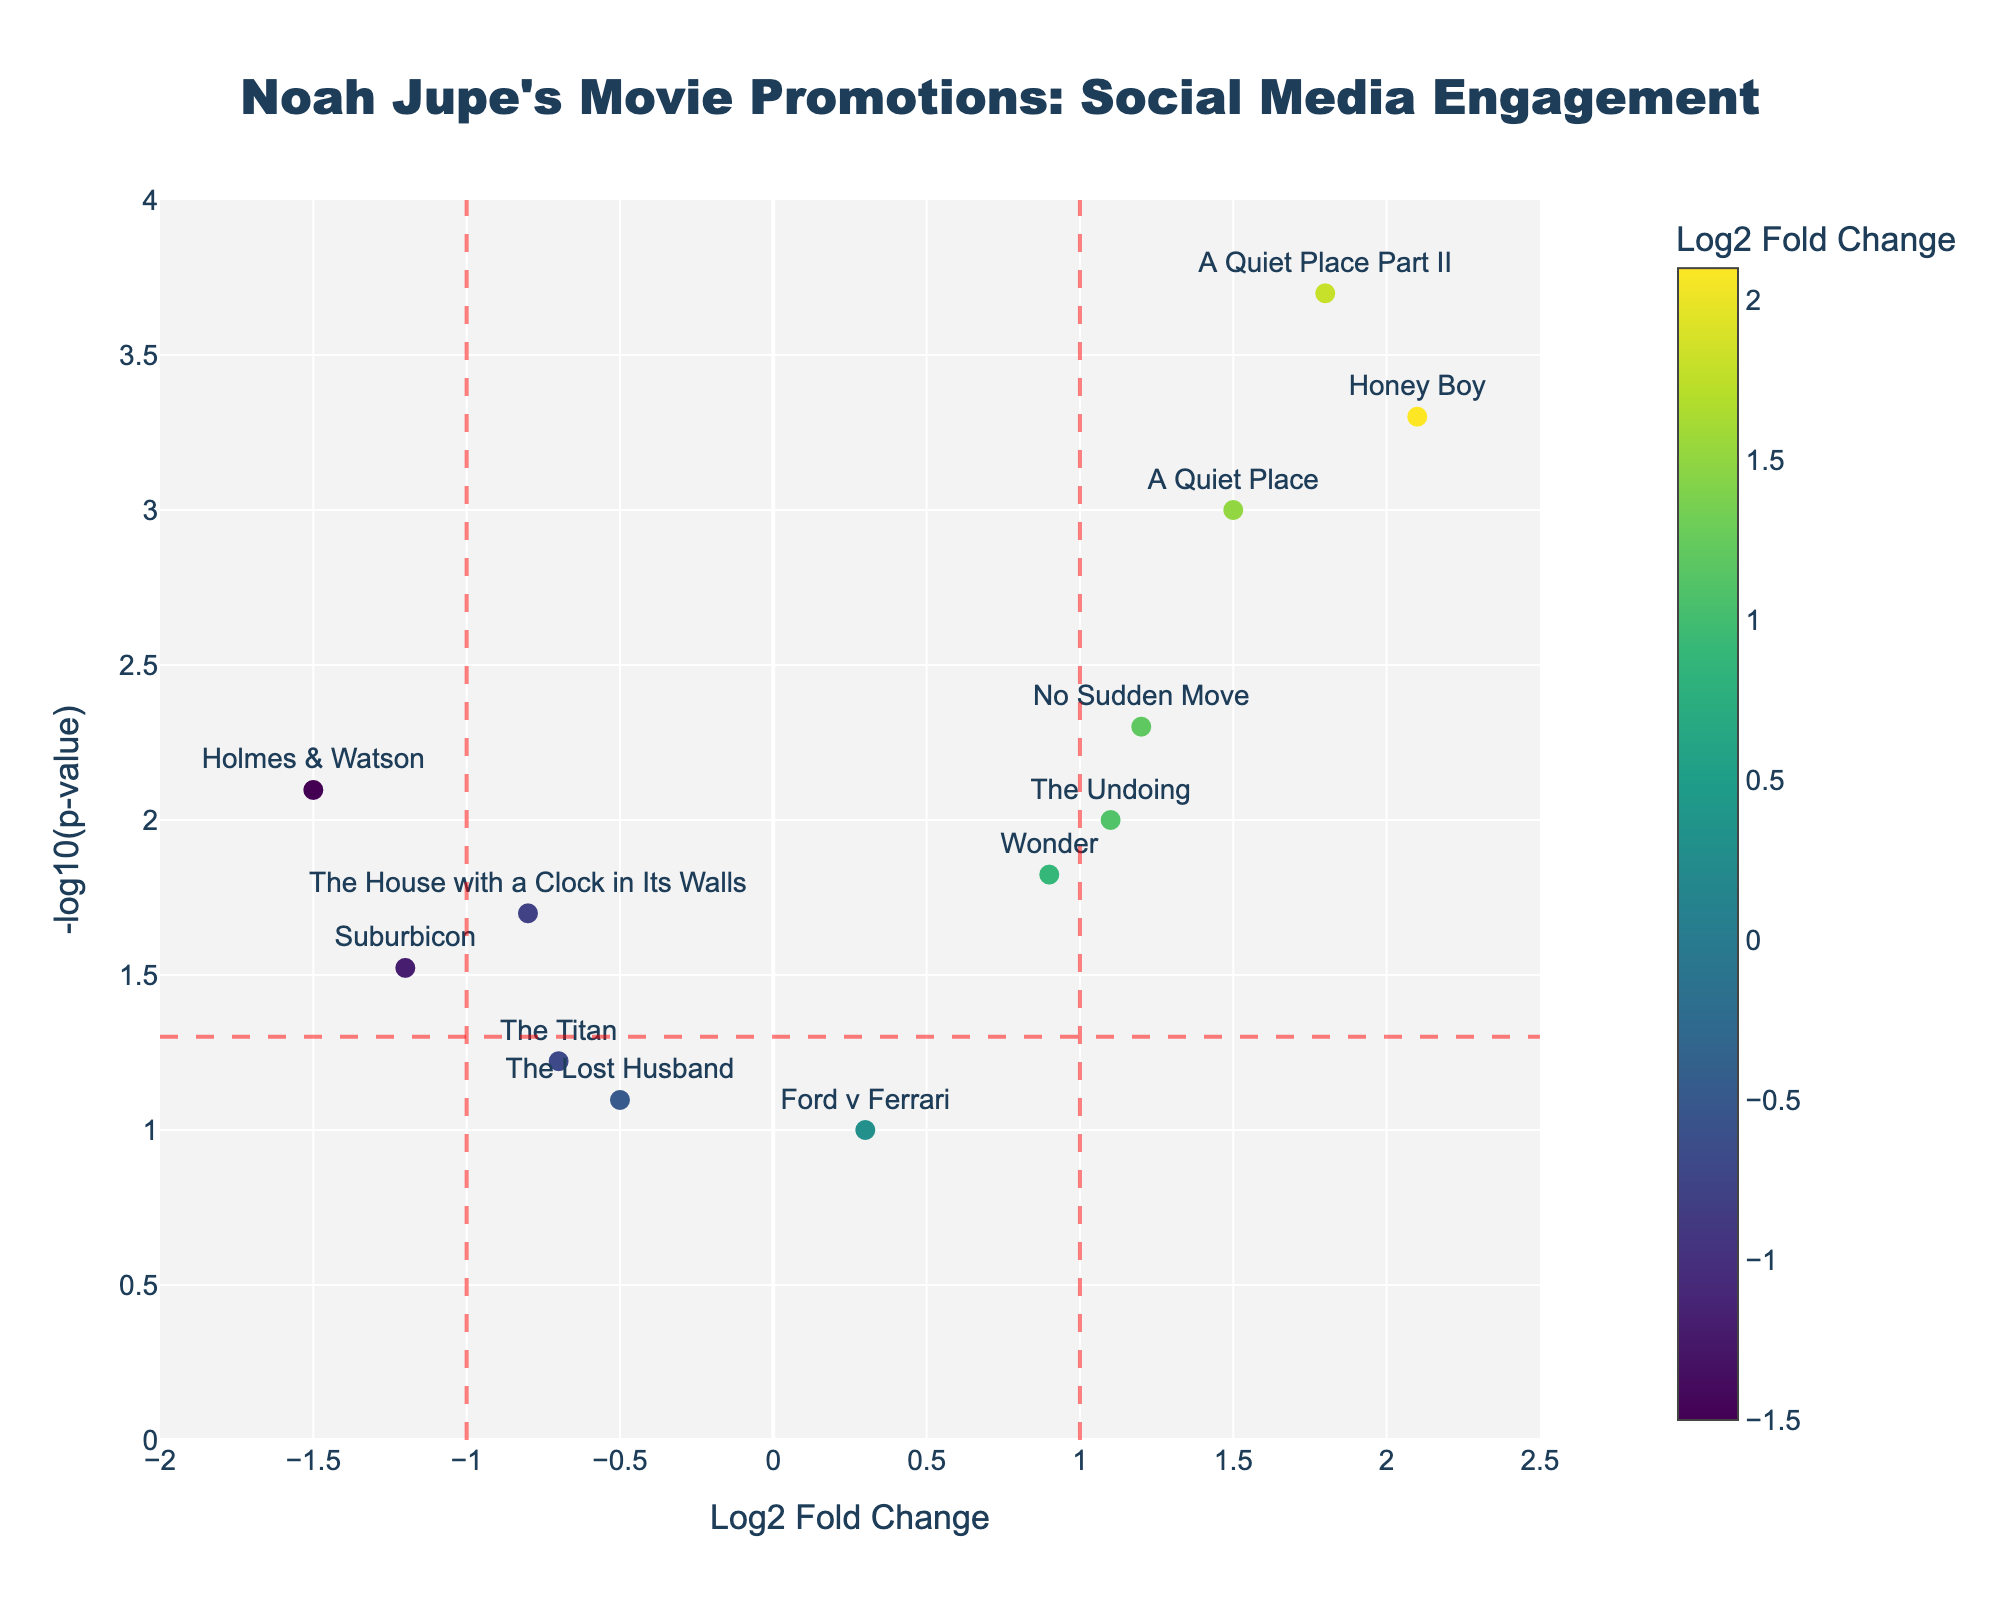What's the title of the plot? The title is located at the top center of the plot and reads "Noah Jupe's Movie Promotions: Social Media Engagement".
Answer: Noah Jupe's Movie Promotions: Social Media Engagement Which axis represents the Log2 Fold Change? The x-axis represents the Log2 Fold Change, as indicated by the label below it.
Answer: x-axis How many movies have a Log2 Fold Change greater than 1? There are four data points to the right of the x=1 vertical line. These represent the movies with a Log2 Fold Change greater than 1.
Answer: 4 What's the color scheme used for the markers? The markers are colored using the Viridis colorscale, as indicated by the presence of a colorbar representing this color scheme.
Answer: Viridis What is the Log2 Fold Change of the movie "Honey Boy"? By examining the text labels beside the data points, "Honey Boy" is positioned at a Log2 Fold Change of 2.1.
Answer: 2.1 Which movie has the lowest p-value? The movie with the highest y value, representing the lowest p-value, is "A Quiet Place Part II".
Answer: A Quiet Place Part II Is there any movie with a negative Log2 Fold Change and a p-value less than 0.05? There are three movies with negative Log2 Fold Change (left of x=-1) within the dashed horizontal line at -log10(0.05): "The House with a Clock in Its Walls", "Suburbicon", and "Holmes & Watson".
Answer: Yes Which movie has the highest social media engagement based on the Log2 Fold Change? "Honey Boy" has the highest Log2 Fold Change at 2.1, indicating the highest social media engagement.
Answer: Honey Boy Compare the social media engagement of "A Quiet Place" to "A Quiet Place Part II". By comparing the positions, "A Quiet Place Part II" (1.8) has a higher Log2 Fold Change than "A Quiet Place" (1.5).
Answer: A Quiet Place Part II > A Quiet Place How many movies have a significant engagement (p-value < 0.05)? Movies below the dotted horizontal line (-log10(0.05) ~ 1.30) count as having significant engagement: "The House with a Clock in Its Walls", "A Quiet Place", "Wonder", "Honey Boy", "No Sudden Move", "A Quiet Place Part II", "The Undoing", "Suburbicon", and "Holmes & Watson".
Answer: 9 